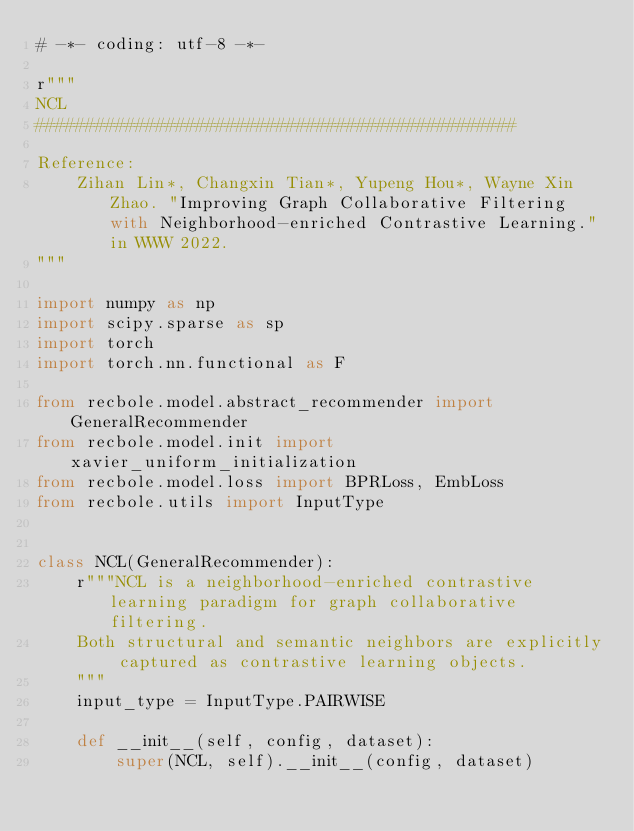<code> <loc_0><loc_0><loc_500><loc_500><_Python_># -*- coding: utf-8 -*-

r"""
NCL
################################################

Reference:
    Zihan Lin*, Changxin Tian*, Yupeng Hou*, Wayne Xin Zhao. "Improving Graph Collaborative Filtering with Neighborhood-enriched Contrastive Learning." in WWW 2022.
"""

import numpy as np
import scipy.sparse as sp
import torch
import torch.nn.functional as F

from recbole.model.abstract_recommender import GeneralRecommender
from recbole.model.init import xavier_uniform_initialization
from recbole.model.loss import BPRLoss, EmbLoss
from recbole.utils import InputType


class NCL(GeneralRecommender):
    r"""NCL is a neighborhood-enriched contrastive learning paradigm for graph collaborative filtering.
    Both structural and semantic neighbors are explicitly captured as contrastive learning objects.
    """
    input_type = InputType.PAIRWISE

    def __init__(self, config, dataset):
        super(NCL, self).__init__(config, dataset)
</code> 